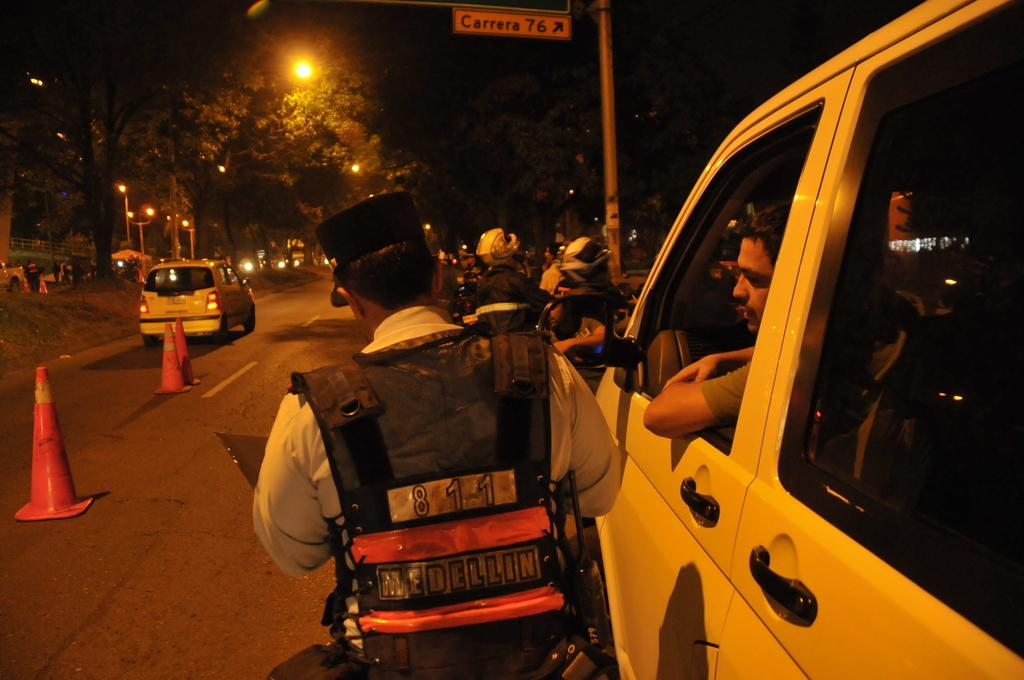Provide a one-sentence caption for the provided image. A man wearing an 8 1 1 vest is speaking to another man in a vehicle near Carrera 76. 